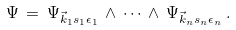Convert formula to latex. <formula><loc_0><loc_0><loc_500><loc_500>\Psi \, = \, \Psi _ { \vec { k } _ { 1 } s _ { 1 } \epsilon _ { 1 } } \, \wedge \, \cdots \, \wedge \, \Psi _ { \vec { k } _ { n } s _ { n } \epsilon _ { n } } \, .</formula> 